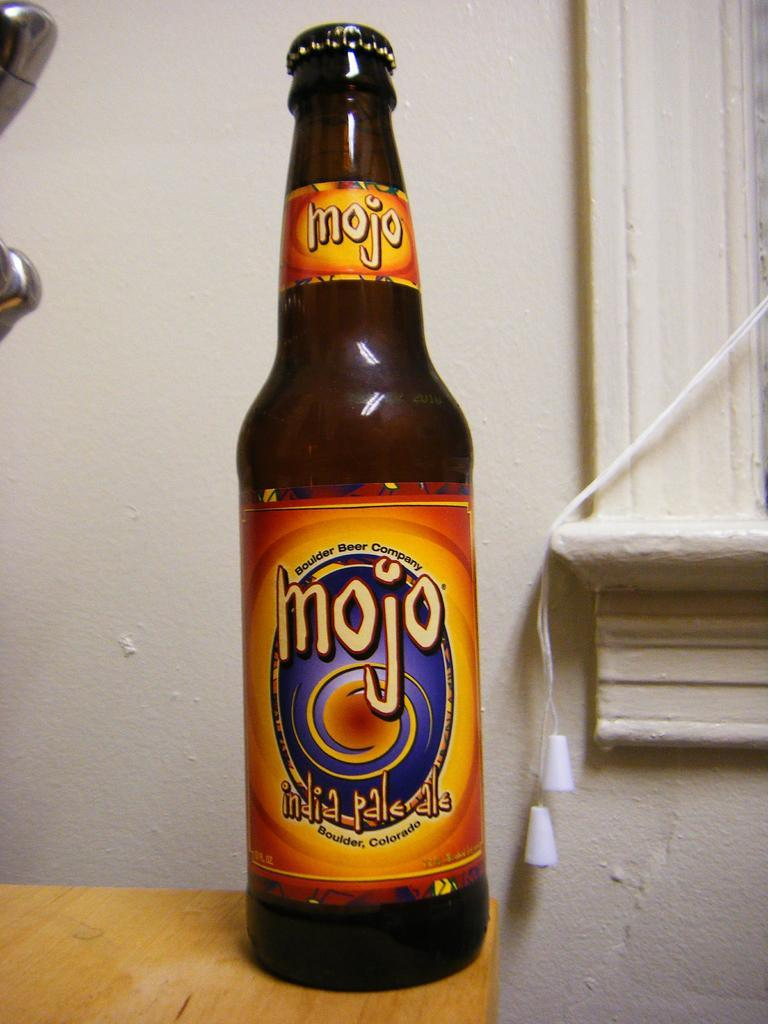<image>
Render a clear and concise summary of the photo. A bottle of Mojo India Pale Ale has an orange colored label. 